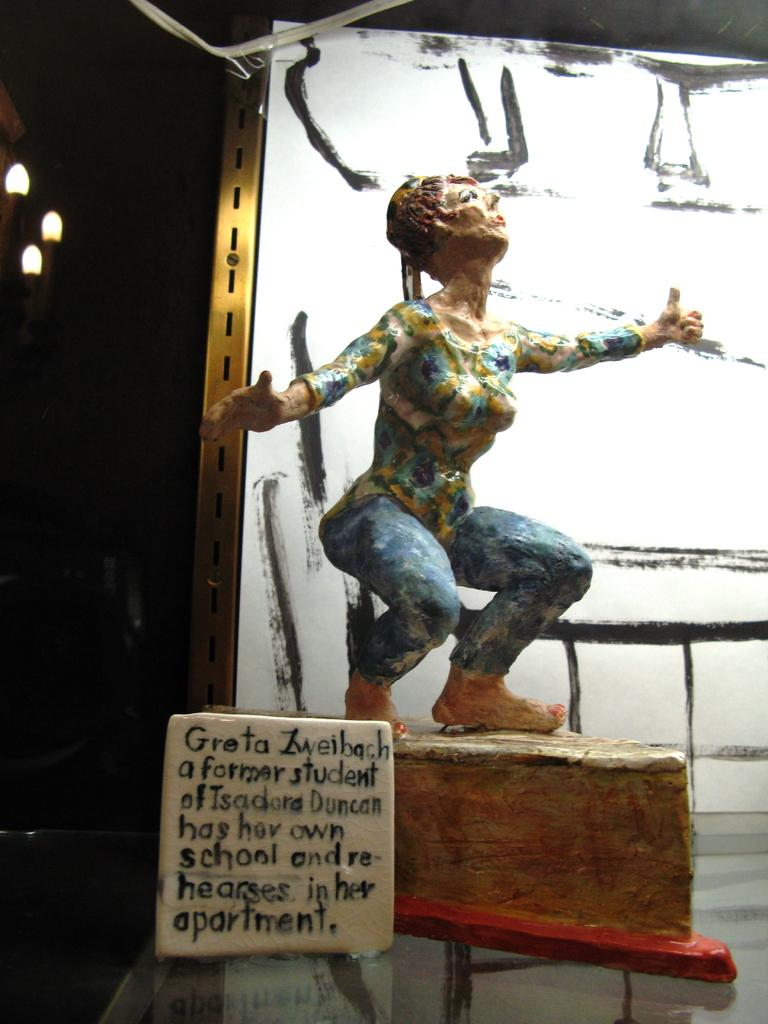What is the main subject in the center of the image? There is a sculpture in the center of the image. What can be seen in the foreground of the image? There is something written on a stone in the foreground. What can be seen in the background of the image? There are lights and a hoarding in the background of the image. What type of rhythm does the crow exhibit in the image? There is no crow present in the image, so it is not possible to determine the rhythm it might exhibit. 